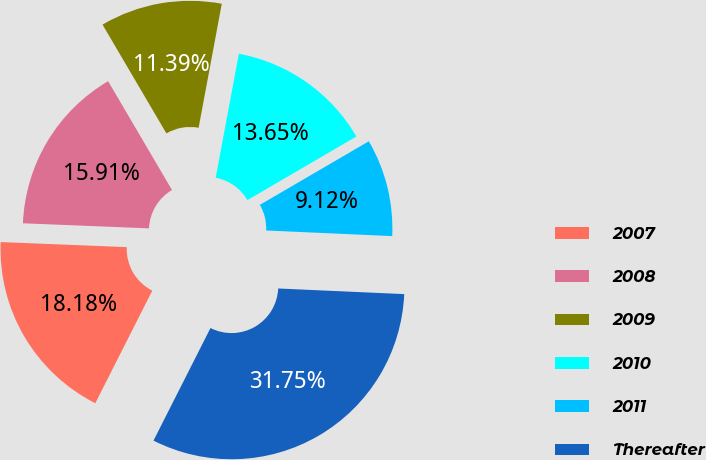Convert chart. <chart><loc_0><loc_0><loc_500><loc_500><pie_chart><fcel>2007<fcel>2008<fcel>2009<fcel>2010<fcel>2011<fcel>Thereafter<nl><fcel>18.18%<fcel>15.91%<fcel>11.39%<fcel>13.65%<fcel>9.12%<fcel>31.75%<nl></chart> 